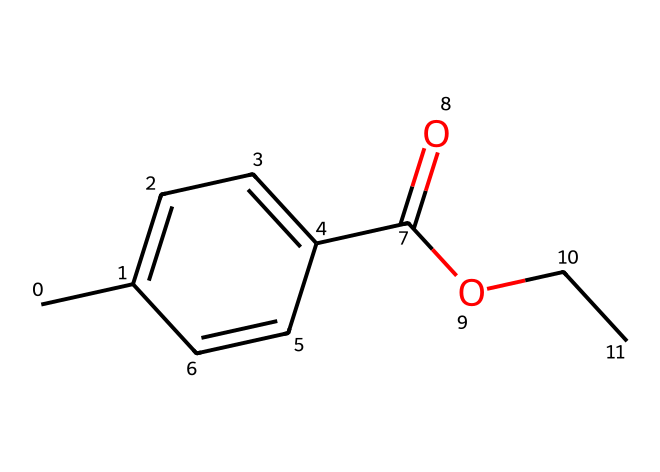What is the main functional group present in this compound? The chemical structure includes a carboxylic acid group (-COOH) since there is a carbonyl group (C=O) directly attached to a hydroxyl group (OH).
Answer: carboxylic acid How many carbon atoms are present in the compound? By analyzing the SMILES representation, we count the number of 'C' characters, which indicates the presence of nine carbon atoms in total (including those in the aromatic ring).
Answer: nine What type of bond is present between the aromatic carbon atoms? The aromatic carbon atoms are connected by a combination of single and double bonds, specifically alternating double bonds, which is characteristic of aromatic compounds.
Answer: alternating bonds Does this compound contain any nitrogen atoms? Upon inspecting the SMILES, we find no 'N' characters, which indicates that this molecule does not include nitrogen atoms.
Answer: no What is the degree of saturation of this compound? To determine the degree of saturation, we can assess the presence of double bonds and rings. In this case, the alternating double bonds in the ring and one double bond from the carbonyl contribute to a C, H ratio showing saturation.
Answer: five Is this compound likely to be polar or nonpolar? The presence of the hydrophilic carboxylic acid group suggests the compound has regions that can interact with water, making it likely to be polar overall.
Answer: polar 